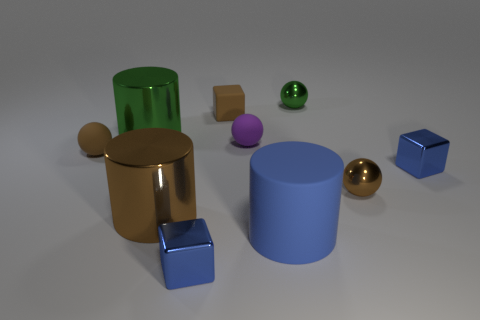Subtract all purple spheres. How many spheres are left? 3 Subtract all tiny brown rubber balls. How many balls are left? 3 Subtract all yellow spheres. Subtract all gray cubes. How many spheres are left? 4 Subtract all cylinders. How many objects are left? 7 Add 7 green metallic cylinders. How many green metallic cylinders are left? 8 Add 5 blue metallic things. How many blue metallic things exist? 7 Subtract 1 brown spheres. How many objects are left? 9 Subtract all matte objects. Subtract all blue matte cylinders. How many objects are left? 5 